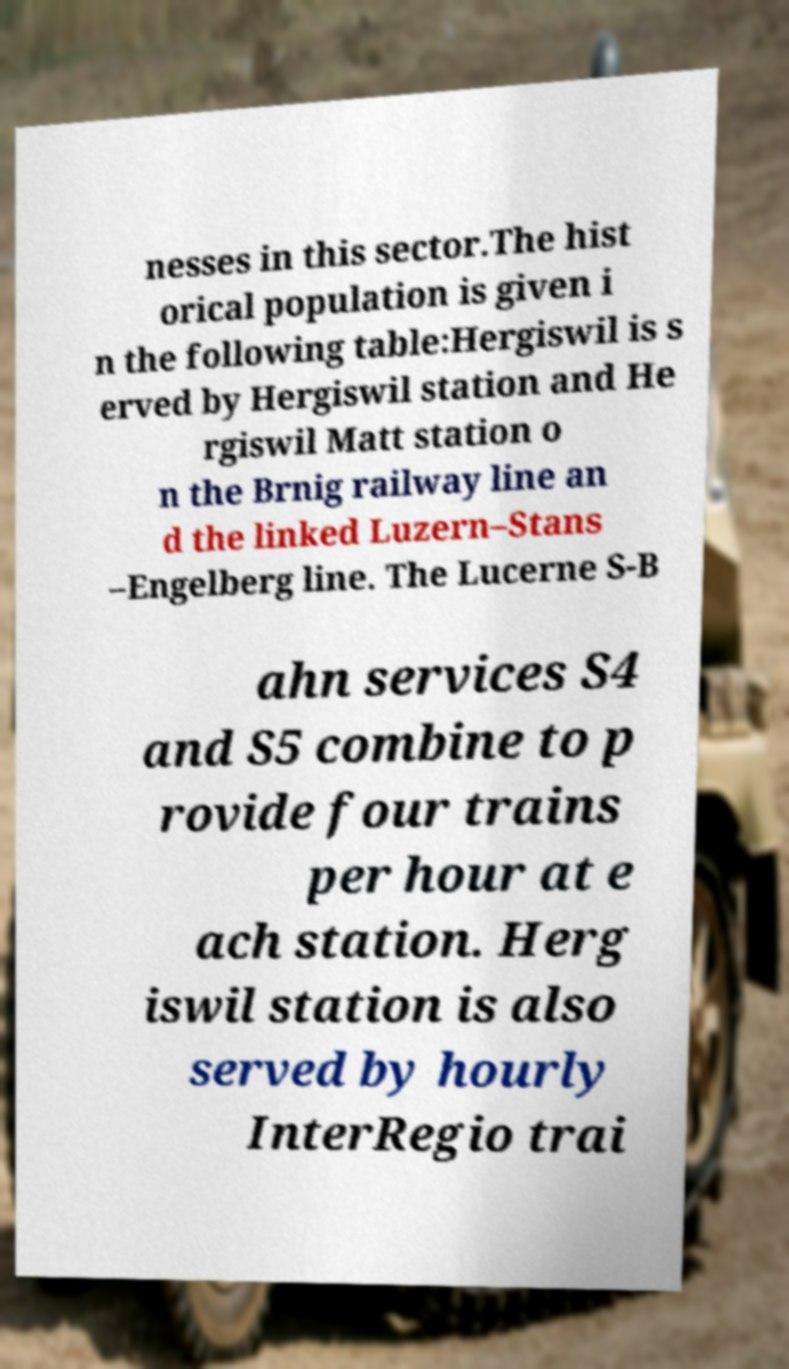Can you read and provide the text displayed in the image?This photo seems to have some interesting text. Can you extract and type it out for me? nesses in this sector.The hist orical population is given i n the following table:Hergiswil is s erved by Hergiswil station and He rgiswil Matt station o n the Brnig railway line an d the linked Luzern–Stans –Engelberg line. The Lucerne S-B ahn services S4 and S5 combine to p rovide four trains per hour at e ach station. Herg iswil station is also served by hourly InterRegio trai 